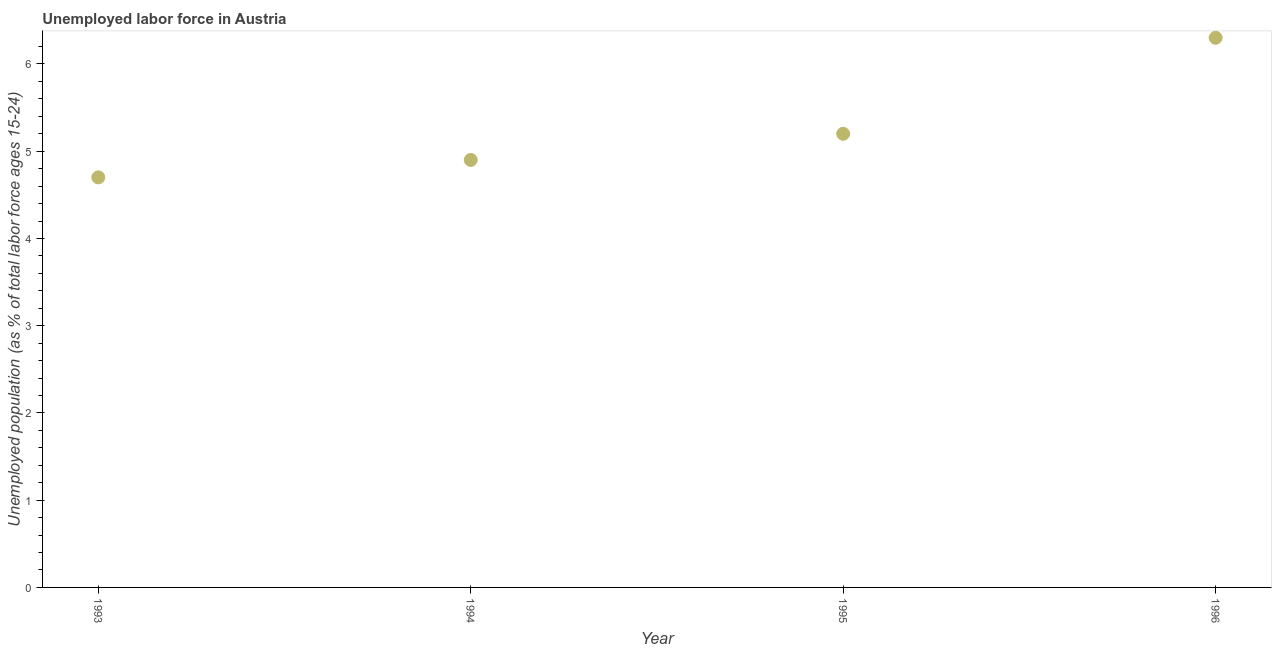What is the total unemployed youth population in 1994?
Make the answer very short. 4.9. Across all years, what is the maximum total unemployed youth population?
Your answer should be very brief. 6.3. Across all years, what is the minimum total unemployed youth population?
Offer a very short reply. 4.7. In which year was the total unemployed youth population maximum?
Give a very brief answer. 1996. In which year was the total unemployed youth population minimum?
Your answer should be very brief. 1993. What is the sum of the total unemployed youth population?
Make the answer very short. 21.1. What is the difference between the total unemployed youth population in 1993 and 1994?
Keep it short and to the point. -0.2. What is the average total unemployed youth population per year?
Offer a very short reply. 5.27. What is the median total unemployed youth population?
Ensure brevity in your answer.  5.05. In how many years, is the total unemployed youth population greater than 0.8 %?
Offer a terse response. 4. Do a majority of the years between 1994 and 1993 (inclusive) have total unemployed youth population greater than 1.6 %?
Make the answer very short. No. What is the ratio of the total unemployed youth population in 1993 to that in 1994?
Ensure brevity in your answer.  0.96. Is the difference between the total unemployed youth population in 1993 and 1995 greater than the difference between any two years?
Offer a very short reply. No. What is the difference between the highest and the second highest total unemployed youth population?
Make the answer very short. 1.1. What is the difference between the highest and the lowest total unemployed youth population?
Your answer should be compact. 1.6. How many years are there in the graph?
Offer a terse response. 4. What is the difference between two consecutive major ticks on the Y-axis?
Your response must be concise. 1. Are the values on the major ticks of Y-axis written in scientific E-notation?
Provide a short and direct response. No. Does the graph contain any zero values?
Your answer should be very brief. No. Does the graph contain grids?
Offer a terse response. No. What is the title of the graph?
Give a very brief answer. Unemployed labor force in Austria. What is the label or title of the X-axis?
Ensure brevity in your answer.  Year. What is the label or title of the Y-axis?
Make the answer very short. Unemployed population (as % of total labor force ages 15-24). What is the Unemployed population (as % of total labor force ages 15-24) in 1993?
Keep it short and to the point. 4.7. What is the Unemployed population (as % of total labor force ages 15-24) in 1994?
Offer a very short reply. 4.9. What is the Unemployed population (as % of total labor force ages 15-24) in 1995?
Your response must be concise. 5.2. What is the Unemployed population (as % of total labor force ages 15-24) in 1996?
Your response must be concise. 6.3. What is the difference between the Unemployed population (as % of total labor force ages 15-24) in 1993 and 1995?
Keep it short and to the point. -0.5. What is the difference between the Unemployed population (as % of total labor force ages 15-24) in 1994 and 1996?
Keep it short and to the point. -1.4. What is the ratio of the Unemployed population (as % of total labor force ages 15-24) in 1993 to that in 1994?
Provide a succinct answer. 0.96. What is the ratio of the Unemployed population (as % of total labor force ages 15-24) in 1993 to that in 1995?
Your answer should be compact. 0.9. What is the ratio of the Unemployed population (as % of total labor force ages 15-24) in 1993 to that in 1996?
Make the answer very short. 0.75. What is the ratio of the Unemployed population (as % of total labor force ages 15-24) in 1994 to that in 1995?
Your response must be concise. 0.94. What is the ratio of the Unemployed population (as % of total labor force ages 15-24) in 1994 to that in 1996?
Make the answer very short. 0.78. What is the ratio of the Unemployed population (as % of total labor force ages 15-24) in 1995 to that in 1996?
Offer a terse response. 0.82. 